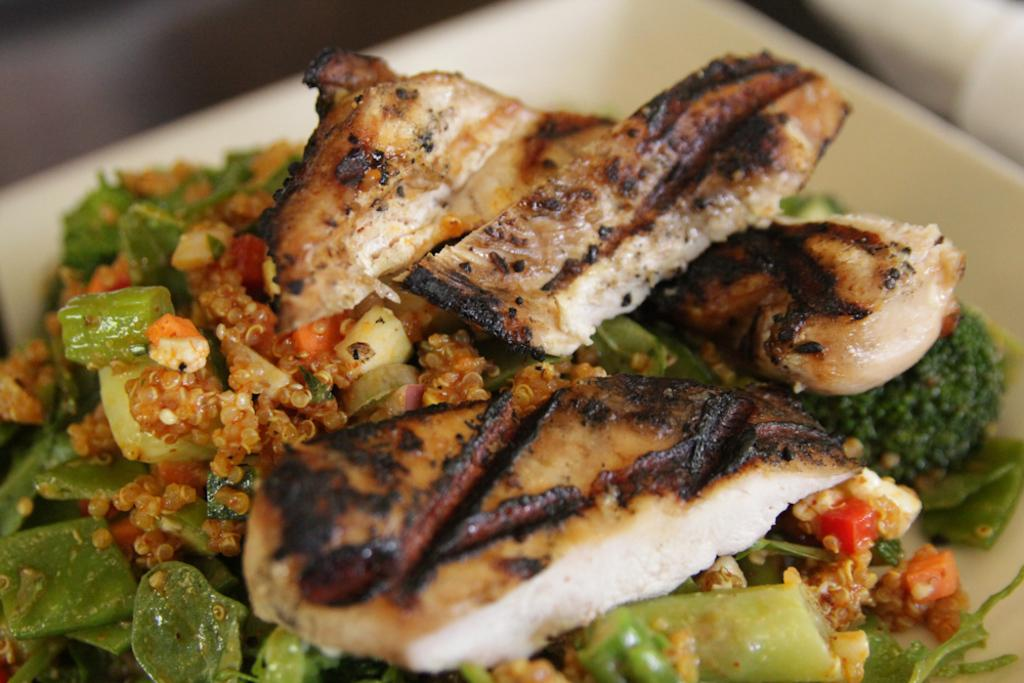What is on the plate in the image? There is food on a plate in the image. What type of pleasure can be seen enjoying the food in the image? There is no indication of pleasure or any beings enjoying the food in the image. 